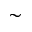<formula> <loc_0><loc_0><loc_500><loc_500>\sim</formula> 